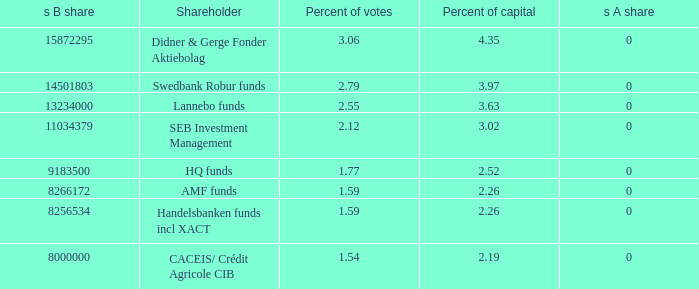What is the s B share for the shareholder that has 2.55 percent of votes?  13234000.0. Could you parse the entire table as a dict? {'header': ['s B share', 'Shareholder', 'Percent of votes', 'Percent of capital', 's A share'], 'rows': [['15872295', 'Didner & Gerge Fonder Aktiebolag', '3.06', '4.35', '0'], ['14501803', 'Swedbank Robur funds', '2.79', '3.97', '0'], ['13234000', 'Lannebo funds', '2.55', '3.63', '0'], ['11034379', 'SEB Investment Management', '2.12', '3.02', '0'], ['9183500', 'HQ funds', '1.77', '2.52', '0'], ['8266172', 'AMF funds', '1.59', '2.26', '0'], ['8256534', 'Handelsbanken funds incl XACT', '1.59', '2.26', '0'], ['8000000', 'CACEIS/ Crédit Agricole CIB', '1.54', '2.19', '0']]} 